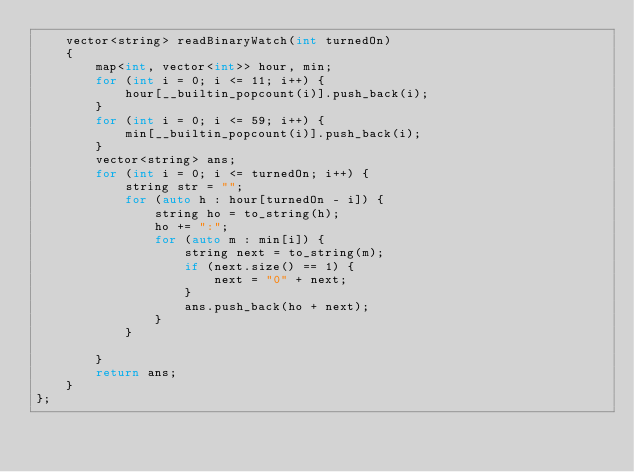<code> <loc_0><loc_0><loc_500><loc_500><_C++_>    vector<string> readBinaryWatch(int turnedOn) 
    {
        map<int, vector<int>> hour, min;
        for (int i = 0; i <= 11; i++) {
            hour[__builtin_popcount(i)].push_back(i);
        }
        for (int i = 0; i <= 59; i++) {
            min[__builtin_popcount(i)].push_back(i);
        }
        vector<string> ans;
        for (int i = 0; i <= turnedOn; i++) {
            string str = "";
            for (auto h : hour[turnedOn - i]) {
                string ho = to_string(h);
                ho += ":";
                for (auto m : min[i]) {
                    string next = to_string(m);
                    if (next.size() == 1) {
                        next = "0" + next;
                    }
                    ans.push_back(ho + next);
                }
            }
            
        }
        return ans;
    }
};</code> 